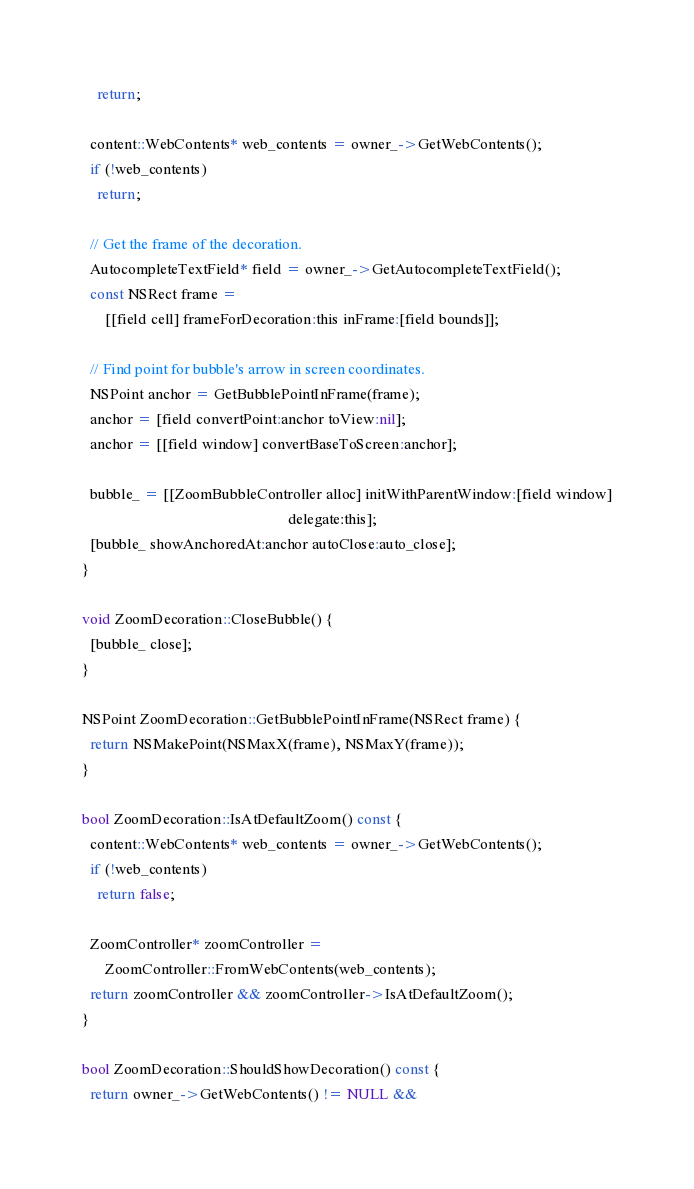<code> <loc_0><loc_0><loc_500><loc_500><_ObjectiveC_>    return;

  content::WebContents* web_contents = owner_->GetWebContents();
  if (!web_contents)
    return;

  // Get the frame of the decoration.
  AutocompleteTextField* field = owner_->GetAutocompleteTextField();
  const NSRect frame =
      [[field cell] frameForDecoration:this inFrame:[field bounds]];

  // Find point for bubble's arrow in screen coordinates.
  NSPoint anchor = GetBubblePointInFrame(frame);
  anchor = [field convertPoint:anchor toView:nil];
  anchor = [[field window] convertBaseToScreen:anchor];

  bubble_ = [[ZoomBubbleController alloc] initWithParentWindow:[field window]
                                                      delegate:this];
  [bubble_ showAnchoredAt:anchor autoClose:auto_close];
}

void ZoomDecoration::CloseBubble() {
  [bubble_ close];
}

NSPoint ZoomDecoration::GetBubblePointInFrame(NSRect frame) {
  return NSMakePoint(NSMaxX(frame), NSMaxY(frame));
}

bool ZoomDecoration::IsAtDefaultZoom() const {
  content::WebContents* web_contents = owner_->GetWebContents();
  if (!web_contents)
    return false;

  ZoomController* zoomController =
      ZoomController::FromWebContents(web_contents);
  return zoomController && zoomController->IsAtDefaultZoom();
}

bool ZoomDecoration::ShouldShowDecoration() const {
  return owner_->GetWebContents() != NULL &&</code> 